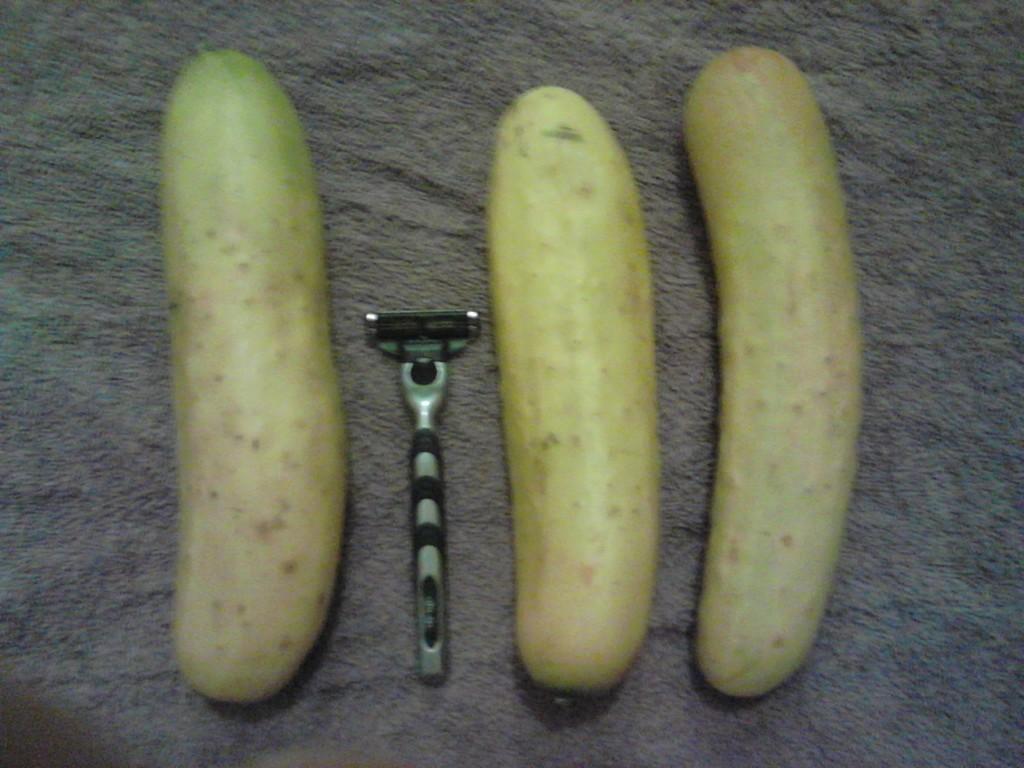How would you summarize this image in a sentence or two? In this picture we can see three cucumbers and a razor on a platform. 